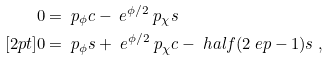<formula> <loc_0><loc_0><loc_500><loc_500>0 & = \ p _ { \phi } c - \ e ^ { \phi / 2 } \ p _ { \chi } s \\ [ 2 p t ] 0 & = \ p _ { \phi } s + \ e ^ { \phi / 2 } \ p _ { \chi } c - \ h a l f ( 2 \ e p - 1 ) s \ ,</formula> 